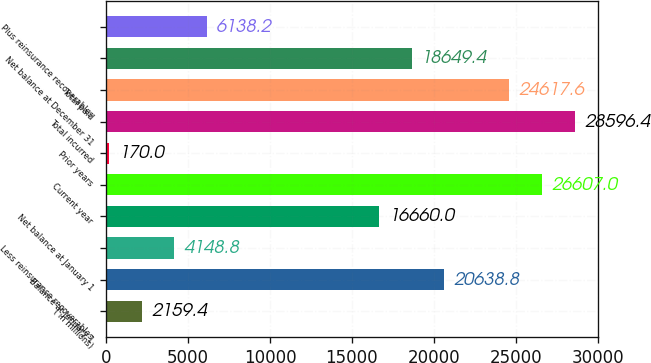Convert chart. <chart><loc_0><loc_0><loc_500><loc_500><bar_chart><fcel>( in millions)<fcel>Balance at January 1<fcel>Less reinsurance recoverables<fcel>Net balance at January 1<fcel>Current year<fcel>Prior years<fcel>Total incurred<fcel>Total paid<fcel>Net balance at December 31<fcel>Plus reinsurance recoverables<nl><fcel>2159.4<fcel>20638.8<fcel>4148.8<fcel>16660<fcel>26607<fcel>170<fcel>28596.4<fcel>24617.6<fcel>18649.4<fcel>6138.2<nl></chart> 